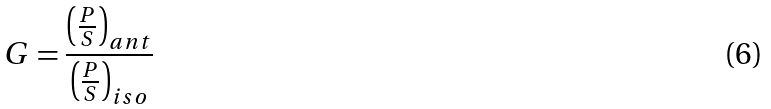Convert formula to latex. <formula><loc_0><loc_0><loc_500><loc_500>G = { \frac { \left ( { \frac { P } { S } } \right ) _ { a n t } } { \left ( { \frac { P } { S } } \right ) _ { i s o } } } \,</formula> 